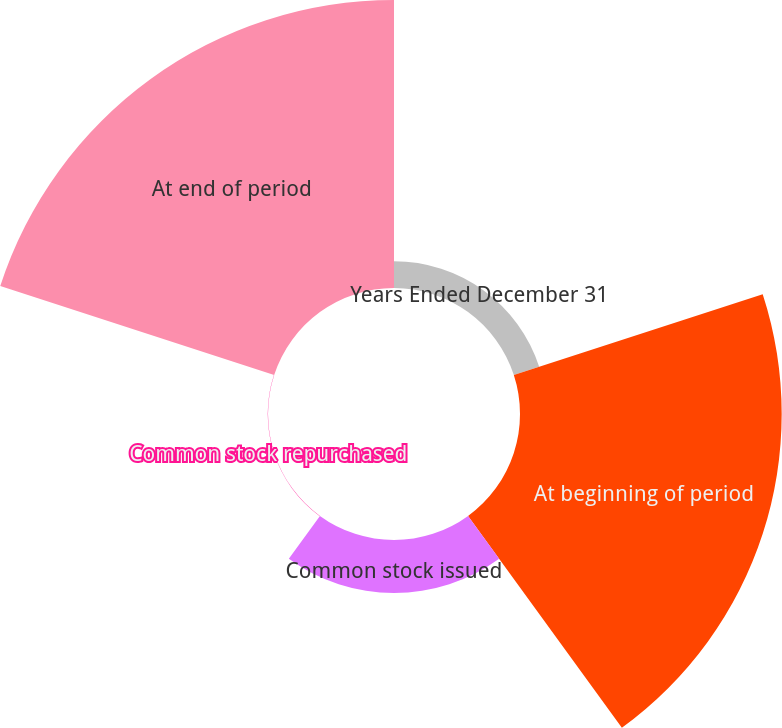Convert chart. <chart><loc_0><loc_0><loc_500><loc_500><pie_chart><fcel>Years Ended December 31<fcel>At beginning of period<fcel>Common stock issued<fcel>Common stock repurchased<fcel>At end of period<nl><fcel>4.23%<fcel>41.57%<fcel>8.41%<fcel>0.04%<fcel>45.75%<nl></chart> 